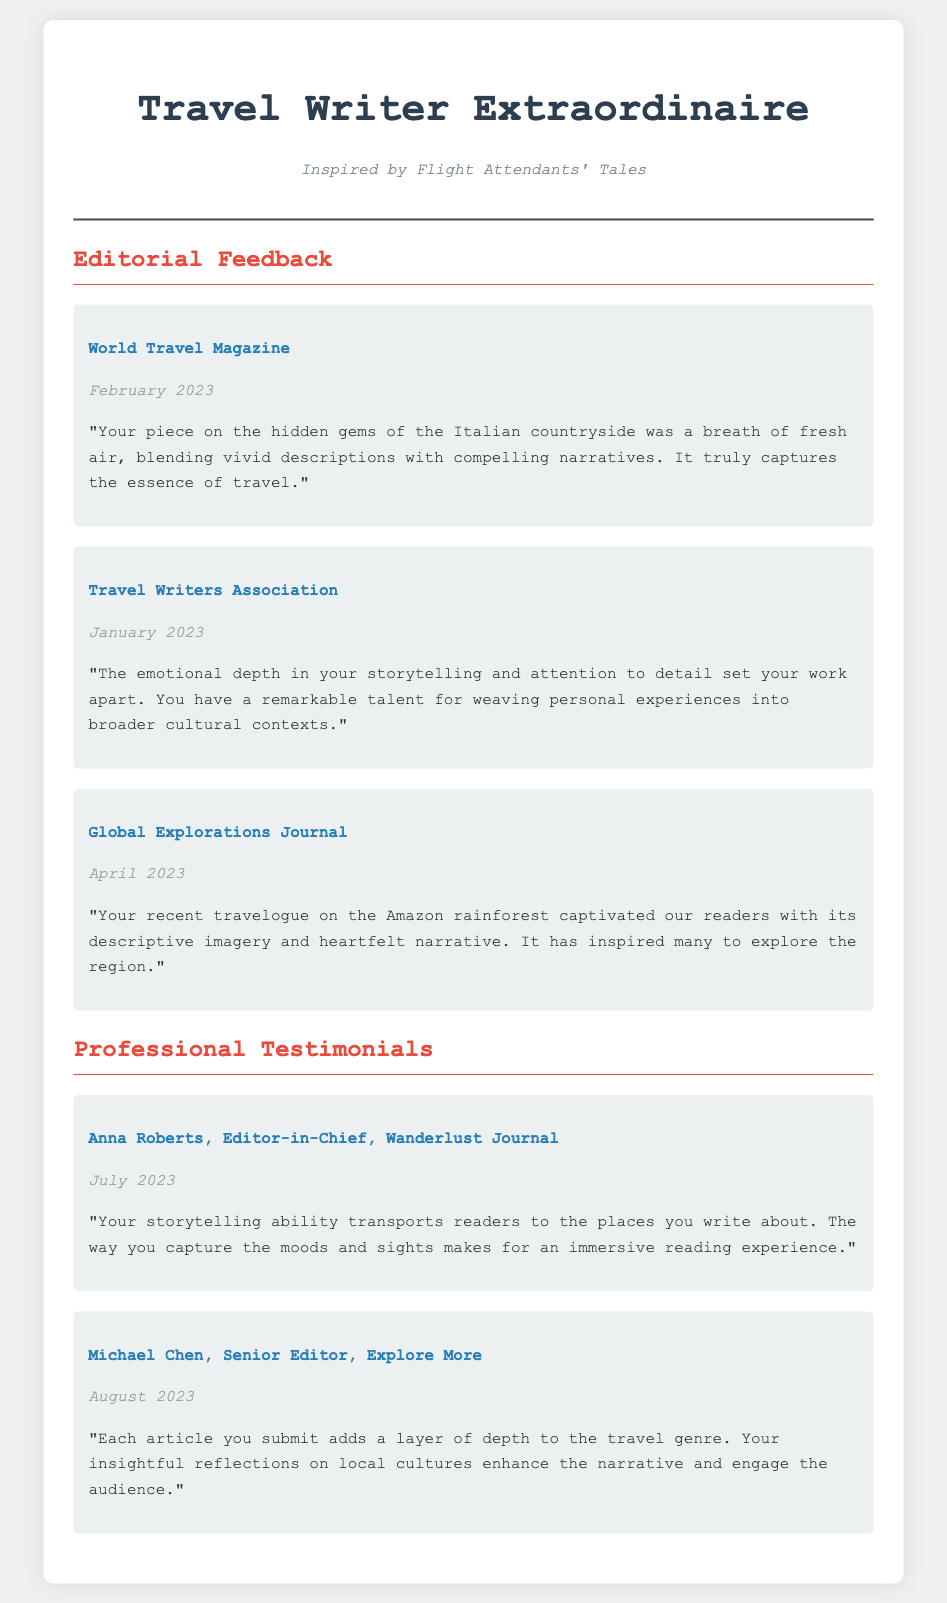what is the name of the magazine that provided feedback in February 2023? The document lists "World Travel Magazine" as the source of feedback in February 2023.
Answer: World Travel Magazine who is the editor-in-chief mentioned in the testimonials? The document mentions "Anna Roberts" as the Editor-in-Chief in the testimonials section.
Answer: Anna Roberts what date was the feedback from the Travel Writers Association? The document states that the feedback from the Travel Writers Association was given in January 2023.
Answer: January 2023 how many testimonials are included in the resume? The document contains a total of two testimonials showcasing feedback from different professionals.
Answer: 2 what aspect of the articles does Michael Chen highlight? Michael Chen emphasizes the "insightful reflections on local cultures" in his testimonial.
Answer: insightful reflections on local cultures which travel piece captivated readers according to Global Explorations Journal? According to the document, the travelogue on the Amazon rainforest captivated readers.
Answer: Amazon rainforest which year was the feedback from World Travel Magazine given? The document indicates that the feedback from World Travel Magazine was given in February 2023.
Answer: 2023 what is the primary focus of the feedback and testimonials? The feedback and testimonials primarily focus on "style, impact, and storytelling elements" in travel writing.
Answer: style, impact, and storytelling elements who provided feedback in April 2023? The document states that "Global Explorations Journal" provided feedback in April 2023.
Answer: Global Explorations Journal 